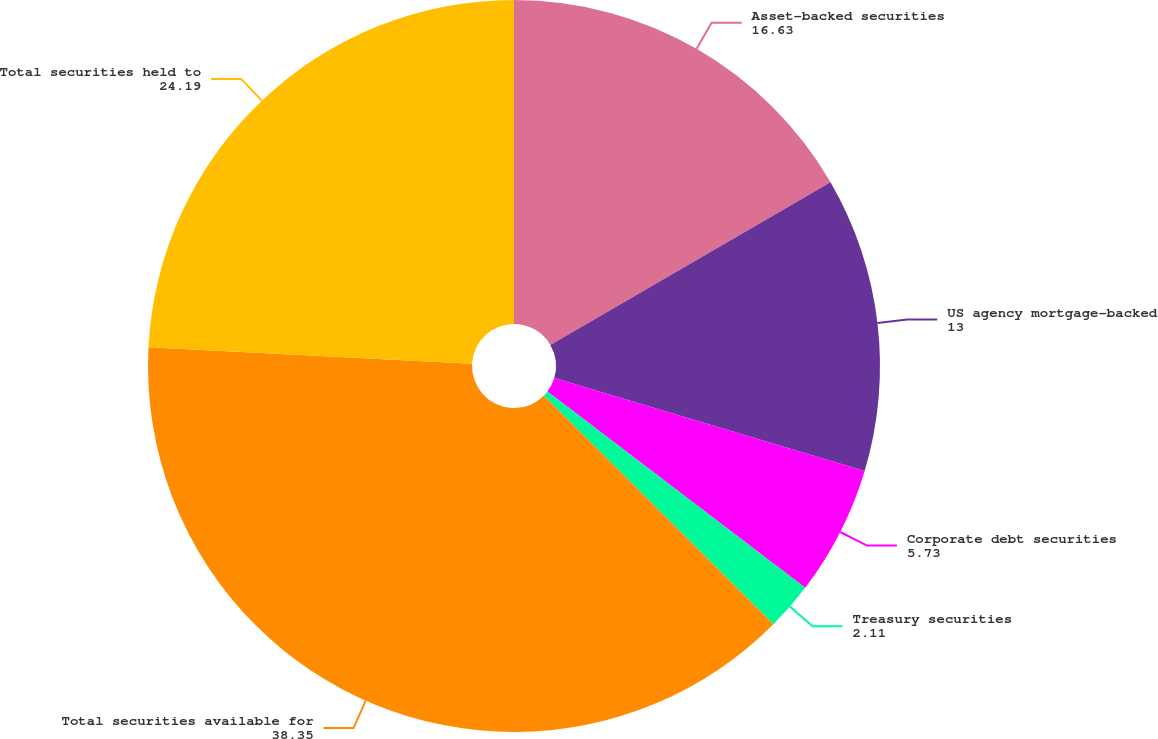<chart> <loc_0><loc_0><loc_500><loc_500><pie_chart><fcel>Asset-backed securities<fcel>US agency mortgage-backed<fcel>Corporate debt securities<fcel>Treasury securities<fcel>Total securities available for<fcel>Total securities held to<nl><fcel>16.63%<fcel>13.0%<fcel>5.73%<fcel>2.11%<fcel>38.35%<fcel>24.19%<nl></chart> 